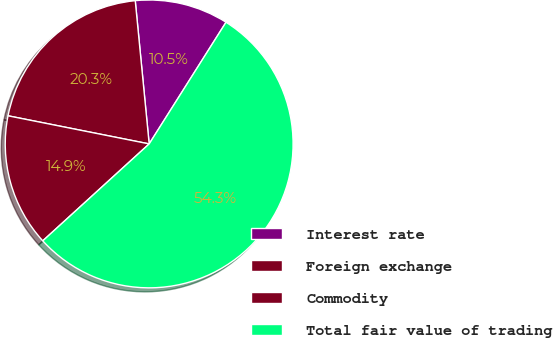<chart> <loc_0><loc_0><loc_500><loc_500><pie_chart><fcel>Interest rate<fcel>Foreign exchange<fcel>Commodity<fcel>Total fair value of trading<nl><fcel>10.51%<fcel>20.33%<fcel>14.89%<fcel>54.28%<nl></chart> 